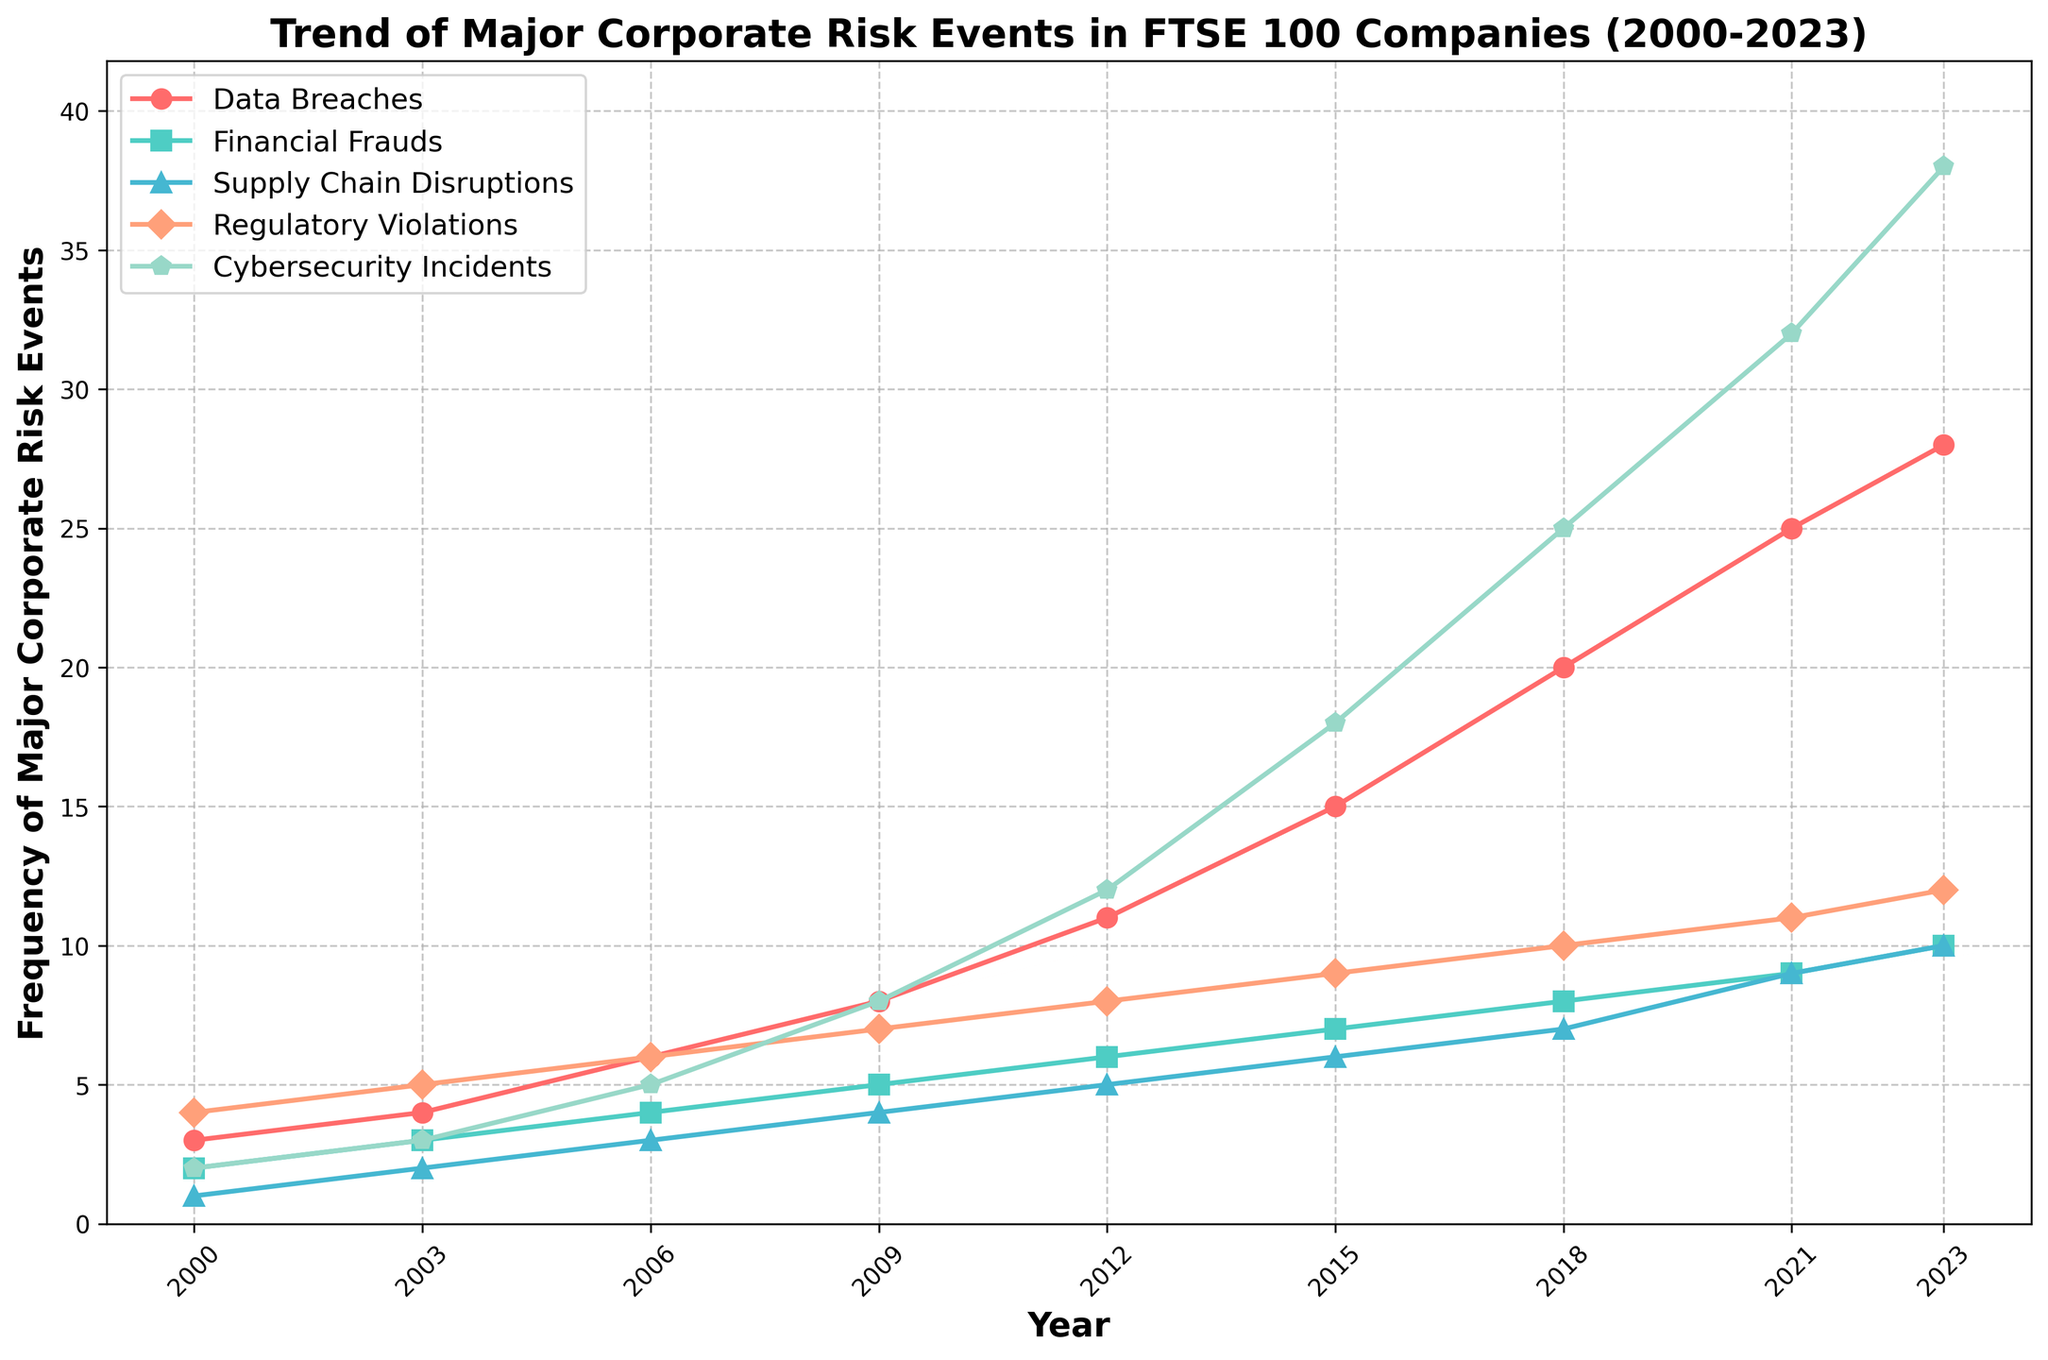What is the most frequent type of major corporate risk event in 2023? To find the most frequent type of major corporate risk event in 2023, observe the highest point on the vertical axis for 2023 across all types. Cybersecurity Incidents have the highest frequency at 38.
Answer: Cybersecurity Incidents How does the frequency of Data Breaches change from 2000 to 2023? Look at the line corresponding to Data Breaches from 2000 to 2023. There is a steady upward trend from 3 in 2000 to 28 in 2023.
Answer: Increased Which type of risk event shows the least increase in frequency from 2000 to 2023? Calculate the change in frequency for each risk type from 2000 to 2023. Financial Frauds increased from 2 to 10, a difference of 8, which is the smallest increase.
Answer: Financial Frauds In which year did Cybersecurity Incidents exceed 20 in frequency? Look at the line for Cybersecurity Incidents and find the year where it first exceeds the value of 20. This happens in 2018.
Answer: 2018 Compare the frequency of Supply Chain Disruptions and Regulatory Violations in 2015. Which is higher? Locate the frequencies for both Supply Chain Disruptions (6) and Regulatory Violations (9) in 2015. Regulatory Violations is higher.
Answer: Regulatory Violations What is the average frequency of Financial Frauds from 2000 to 2023? Sum the data points for Financial Frauds (2, 3, 4, 5, 6, 7, 8, 9, 10) and divide by the number of years (9). (2+3+4+5+6+7+8+9+10) / 9 = 54 / 9 = 6
Answer: 6 What is the total increase in frequency for Regulatory Violations from 2000 to 2023? Subtract the 2000 value (4) from the 2023 value (12). 12 - 4 = 8
Answer: 8 Between 2006 and 2021, which risk type has the greatest increase in frequency? Observe the difference in values between 2006 and 2021 for each risk type. Cybersecurity Incidents increased from 5 to 32, a difference of 27, which is the greatest increase.
Answer: Cybersecurity Incidents 